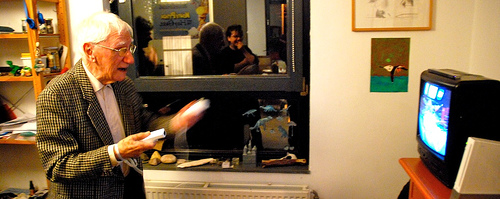<image>What game is the man playing? I am not sure what game the man is playing. It could be a game on the Wii console. What game is the man playing? I don't know what game the man is playing. It can be seen he is playing the Wii. 